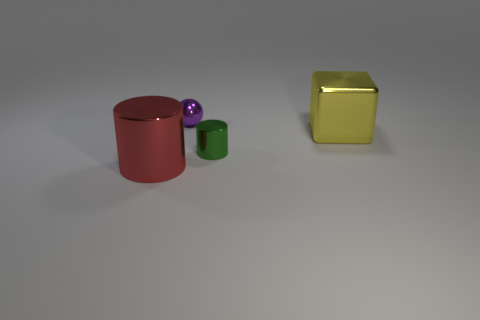Are there any things?
Ensure brevity in your answer.  Yes. There is a shiny object in front of the small metal object that is in front of the large metallic cube to the right of the large red cylinder; what size is it?
Offer a very short reply. Large. What is the shape of the shiny object that is the same size as the green cylinder?
Your response must be concise. Sphere. Are there any other things that are the same material as the green cylinder?
Your answer should be compact. Yes. How many things are either small objects on the right side of the metal sphere or big yellow shiny objects?
Offer a very short reply. 2. There is a green shiny thing that is behind the large shiny thing that is in front of the large shiny block; are there any shiny objects behind it?
Your response must be concise. Yes. How many purple shiny spheres are there?
Keep it short and to the point. 1. What number of things are either small things that are to the left of the tiny green shiny thing or things that are in front of the small purple object?
Offer a very short reply. 4. There is a shiny object that is behind the yellow shiny thing; does it have the same size as the yellow metallic object?
Keep it short and to the point. No. The red object that is the same shape as the tiny green thing is what size?
Offer a very short reply. Large. 